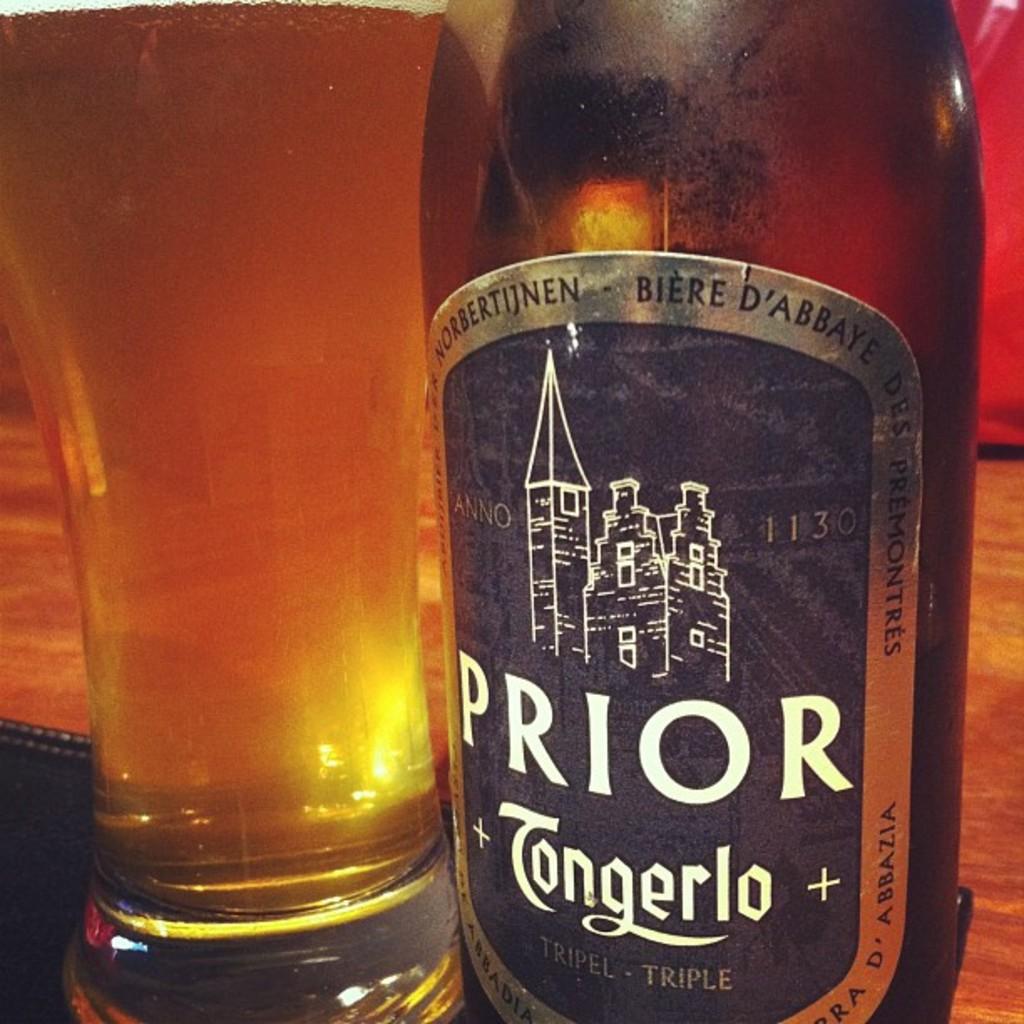What type of drink is this?
Make the answer very short. Beer. 